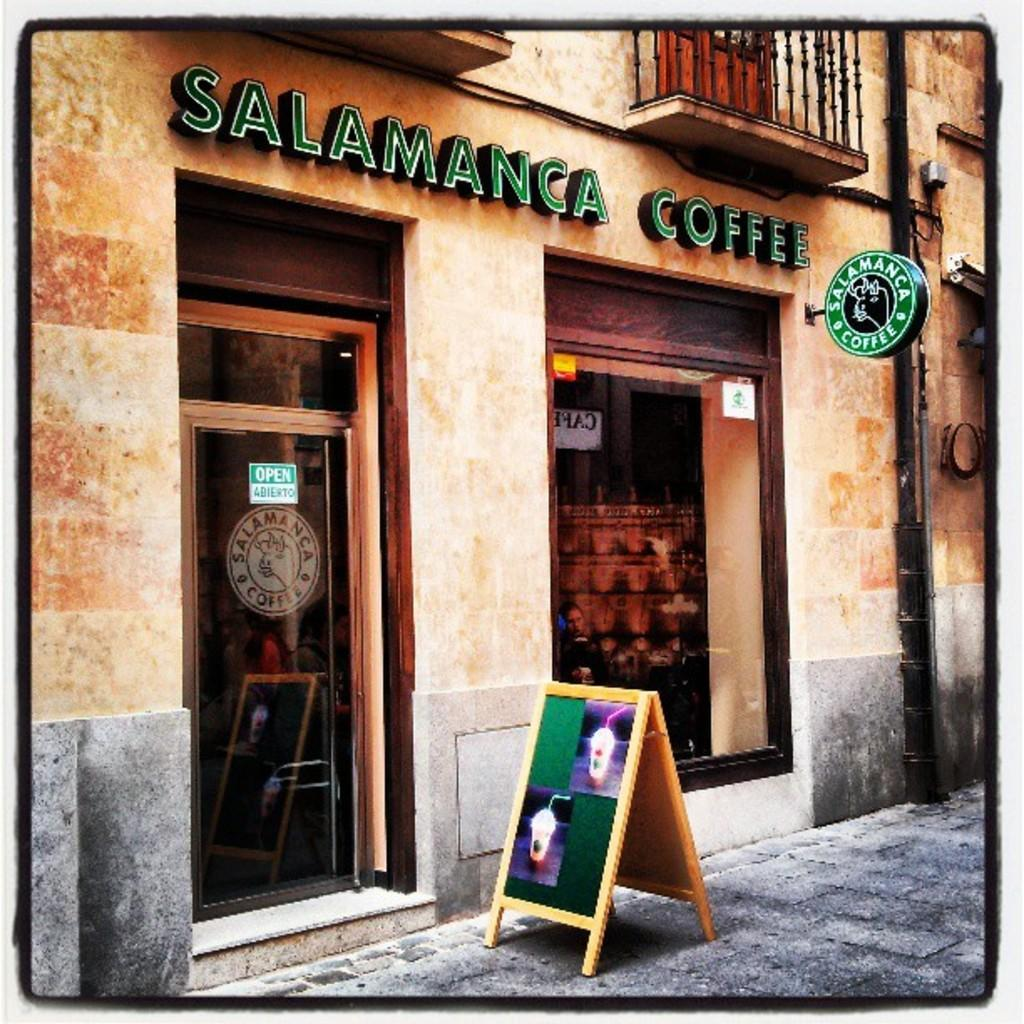Provide a one-sentence caption for the provided image. A coffee shop exterior is shown called Salamanca Coffee. 